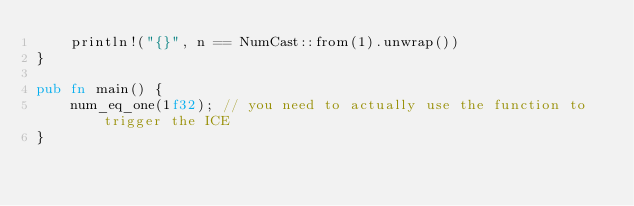<code> <loc_0><loc_0><loc_500><loc_500><_Rust_>    println!("{}", n == NumCast::from(1).unwrap())
}

pub fn main() {
    num_eq_one(1f32); // you need to actually use the function to trigger the ICE
}
</code> 